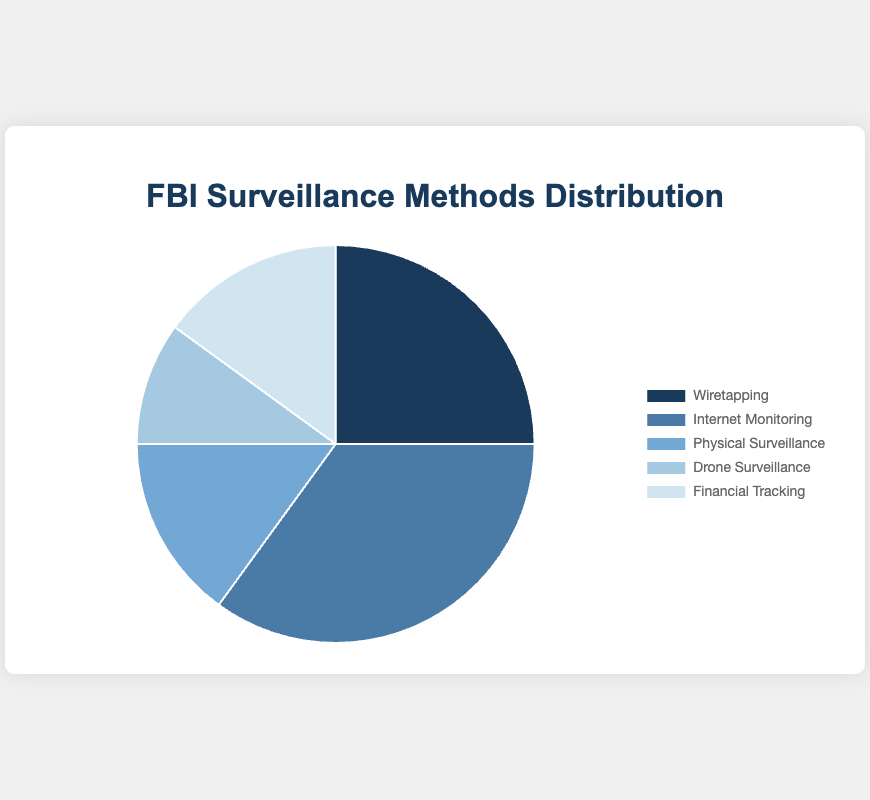What's the most used surveillance method by the FBI? The most used surveillance method can be determined by identifying the largest slice in the pie chart. The largest slice corresponds to "Internet Monitoring".
Answer: Internet Monitoring What is the least utilized surveillance method according to the chart? The least utilized surveillance method is represented by the smallest slice in the pie chart, which is "Drone Surveillance".
Answer: Drone Surveillance What is the combined percentage of Physical Surveillance and Financial Tracking? To find the combined percentage, add the percentages of both methods: Physical Surveillance (15%) + Financial Tracking (15%) = 30%.
Answer: 30% Which methods together account for 50% of the total surveillance methods? Adding the percentages in descending order until 50% is reached: Internet Monitoring (35%) + Wiretapping (25%) = 60%; Internet Monitoring (35%) + Physical Surveillance (15%) = 50%.
Answer: Internet Monitoring and Physical Surveillance How much more prevalent is Internet Monitoring compared to Drone Surveillance? Subtract the percentage of Drone Surveillance from Internet Monitoring: Internet Monitoring (35%) - Drone Surveillance (10%) = 25%.
Answer: 25% What is the average percentage of surveillance methods (use all five methods)? To calculate the average, sum all percentages and divide by the number of methods: (25% + 35% + 15% + 10% + 15%) / 5 = 100% / 5 = 20%.
Answer: 20% Which surveillance method is represented by the darkest color in the pie chart? The darkest color slice in the pie chart represents "Wiretapping".
Answer: Wiretapping Which surveillance method is used equally to Physical Surveillance? According to the pie chart, "Financial Tracking" has the same percentage (15%) as Physical Surveillance.
Answer: Financial Tracking If the FBI decided to double the usage of Drone Surveillance, what would be the new percentage? Doubling the current percentage of Drone Surveillance: 10% * 2 = 20%.
Answer: 20% 